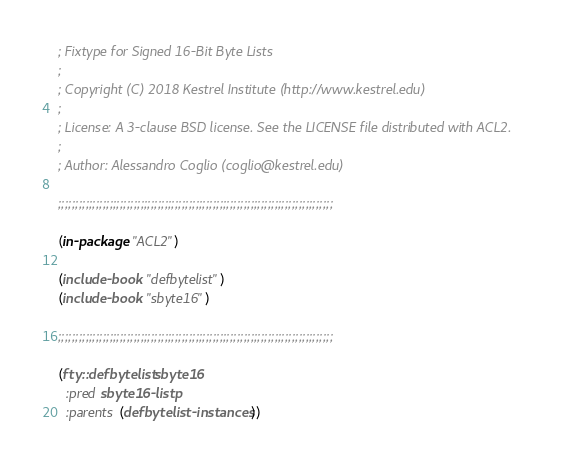<code> <loc_0><loc_0><loc_500><loc_500><_Lisp_>; Fixtype for Signed 16-Bit Byte Lists
;
; Copyright (C) 2018 Kestrel Institute (http://www.kestrel.edu)
;
; License: A 3-clause BSD license. See the LICENSE file distributed with ACL2.
;
; Author: Alessandro Coglio (coglio@kestrel.edu)

;;;;;;;;;;;;;;;;;;;;;;;;;;;;;;;;;;;;;;;;;;;;;;;;;;;;;;;;;;;;;;;;;;;;;;;;;;;;;;;;

(in-package "ACL2")

(include-book "defbytelist")
(include-book "sbyte16")

;;;;;;;;;;;;;;;;;;;;;;;;;;;;;;;;;;;;;;;;;;;;;;;;;;;;;;;;;;;;;;;;;;;;;;;;;;;;;;;;

(fty::defbytelist sbyte16
  :pred sbyte16-listp
  :parents (defbytelist-instances))
</code> 